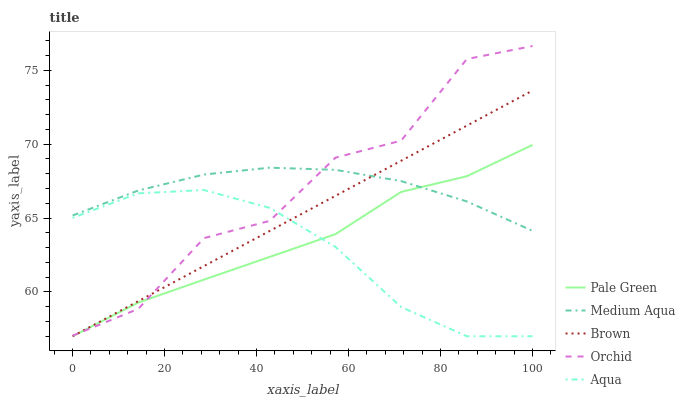Does Aqua have the minimum area under the curve?
Answer yes or no. Yes. Does Medium Aqua have the maximum area under the curve?
Answer yes or no. Yes. Does Brown have the minimum area under the curve?
Answer yes or no. No. Does Brown have the maximum area under the curve?
Answer yes or no. No. Is Brown the smoothest?
Answer yes or no. Yes. Is Orchid the roughest?
Answer yes or no. Yes. Is Pale Green the smoothest?
Answer yes or no. No. Is Pale Green the roughest?
Answer yes or no. No. Does Aqua have the lowest value?
Answer yes or no. Yes. Does Medium Aqua have the lowest value?
Answer yes or no. No. Does Orchid have the highest value?
Answer yes or no. Yes. Does Brown have the highest value?
Answer yes or no. No. Is Aqua less than Medium Aqua?
Answer yes or no. Yes. Is Medium Aqua greater than Aqua?
Answer yes or no. Yes. Does Orchid intersect Aqua?
Answer yes or no. Yes. Is Orchid less than Aqua?
Answer yes or no. No. Is Orchid greater than Aqua?
Answer yes or no. No. Does Aqua intersect Medium Aqua?
Answer yes or no. No. 